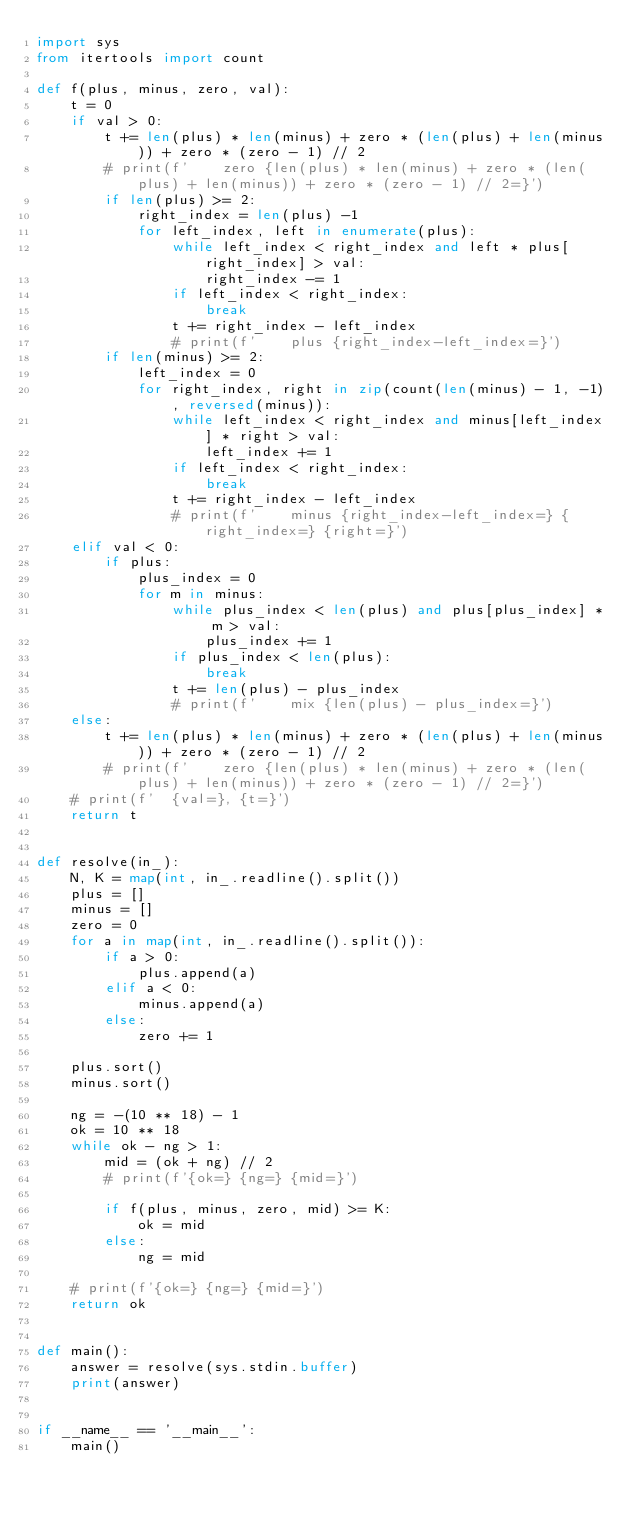Convert code to text. <code><loc_0><loc_0><loc_500><loc_500><_Python_>import sys
from itertools import count

def f(plus, minus, zero, val):
    t = 0
    if val > 0:
        t += len(plus) * len(minus) + zero * (len(plus) + len(minus)) + zero * (zero - 1) // 2
        # print(f'    zero {len(plus) * len(minus) + zero * (len(plus) + len(minus)) + zero * (zero - 1) // 2=}')
        if len(plus) >= 2:
            right_index = len(plus) -1
            for left_index, left in enumerate(plus):
                while left_index < right_index and left * plus[right_index] > val:
                    right_index -= 1
                if left_index < right_index:
                    break
                t += right_index - left_index
                # print(f'    plus {right_index-left_index=}')
        if len(minus) >= 2:
            left_index = 0
            for right_index, right in zip(count(len(minus) - 1, -1), reversed(minus)):
                while left_index < right_index and minus[left_index] * right > val:
                    left_index += 1
                if left_index < right_index:
                    break
                t += right_index - left_index
                # print(f'    minus {right_index-left_index=} {right_index=} {right=}')
    elif val < 0:
        if plus:
            plus_index = 0
            for m in minus:
                while plus_index < len(plus) and plus[plus_index] * m > val:
                    plus_index += 1
                if plus_index < len(plus):
                    break
                t += len(plus) - plus_index
                # print(f'    mix {len(plus) - plus_index=}')
    else:
        t += len(plus) * len(minus) + zero * (len(plus) + len(minus)) + zero * (zero - 1) // 2
        # print(f'    zero {len(plus) * len(minus) + zero * (len(plus) + len(minus)) + zero * (zero - 1) // 2=}')
    # print(f'  {val=}, {t=}')
    return t


def resolve(in_):
    N, K = map(int, in_.readline().split())
    plus = []
    minus = []
    zero = 0
    for a in map(int, in_.readline().split()):
        if a > 0:
            plus.append(a)
        elif a < 0:
            minus.append(a)
        else:
            zero += 1

    plus.sort()
    minus.sort()

    ng = -(10 ** 18) - 1
    ok = 10 ** 18
    while ok - ng > 1:
        mid = (ok + ng) // 2
        # print(f'{ok=} {ng=} {mid=}')

        if f(plus, minus, zero, mid) >= K:
            ok = mid
        else:
            ng = mid

    # print(f'{ok=} {ng=} {mid=}')
    return ok


def main():
    answer = resolve(sys.stdin.buffer)
    print(answer)


if __name__ == '__main__':
    main()
</code> 